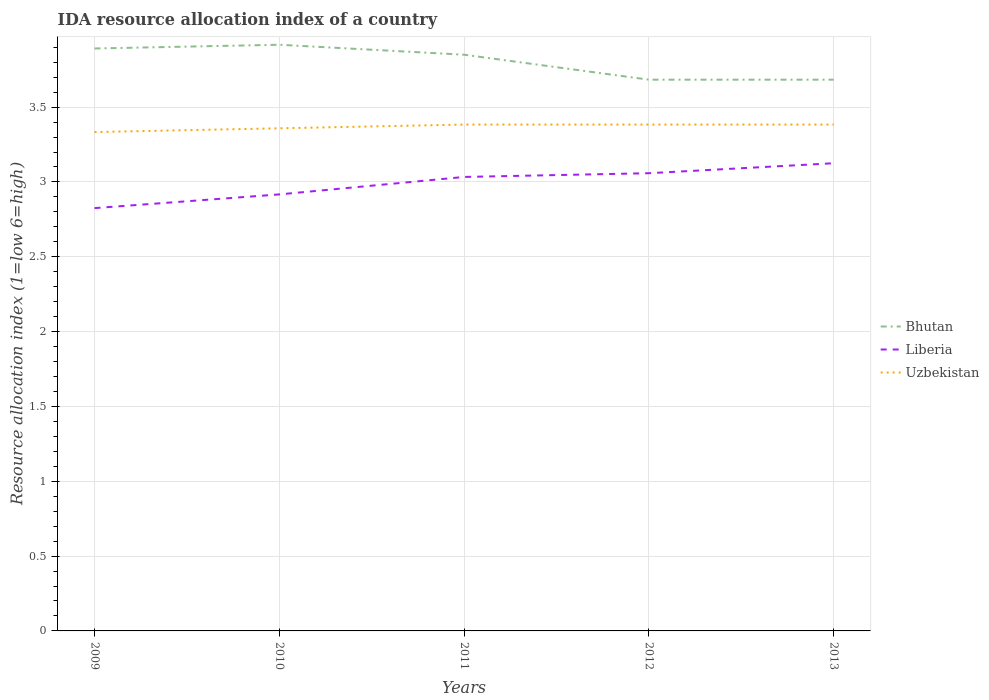How many different coloured lines are there?
Your answer should be compact. 3. Is the number of lines equal to the number of legend labels?
Provide a short and direct response. Yes. Across all years, what is the maximum IDA resource allocation index in Liberia?
Offer a terse response. 2.83. In which year was the IDA resource allocation index in Bhutan maximum?
Your answer should be compact. 2012. What is the total IDA resource allocation index in Uzbekistan in the graph?
Your response must be concise. -0.03. What is the difference between the highest and the second highest IDA resource allocation index in Uzbekistan?
Offer a terse response. 0.05. What is the difference between the highest and the lowest IDA resource allocation index in Uzbekistan?
Your answer should be very brief. 3. How many years are there in the graph?
Keep it short and to the point. 5. Are the values on the major ticks of Y-axis written in scientific E-notation?
Your answer should be very brief. No. Does the graph contain any zero values?
Your answer should be very brief. No. Where does the legend appear in the graph?
Ensure brevity in your answer.  Center right. How are the legend labels stacked?
Offer a terse response. Vertical. What is the title of the graph?
Your response must be concise. IDA resource allocation index of a country. What is the label or title of the X-axis?
Make the answer very short. Years. What is the label or title of the Y-axis?
Your answer should be compact. Resource allocation index (1=low 6=high). What is the Resource allocation index (1=low 6=high) in Bhutan in 2009?
Provide a short and direct response. 3.89. What is the Resource allocation index (1=low 6=high) of Liberia in 2009?
Keep it short and to the point. 2.83. What is the Resource allocation index (1=low 6=high) in Uzbekistan in 2009?
Keep it short and to the point. 3.33. What is the Resource allocation index (1=low 6=high) in Bhutan in 2010?
Your response must be concise. 3.92. What is the Resource allocation index (1=low 6=high) of Liberia in 2010?
Your response must be concise. 2.92. What is the Resource allocation index (1=low 6=high) in Uzbekistan in 2010?
Make the answer very short. 3.36. What is the Resource allocation index (1=low 6=high) in Bhutan in 2011?
Provide a succinct answer. 3.85. What is the Resource allocation index (1=low 6=high) in Liberia in 2011?
Keep it short and to the point. 3.03. What is the Resource allocation index (1=low 6=high) of Uzbekistan in 2011?
Keep it short and to the point. 3.38. What is the Resource allocation index (1=low 6=high) in Bhutan in 2012?
Make the answer very short. 3.68. What is the Resource allocation index (1=low 6=high) of Liberia in 2012?
Ensure brevity in your answer.  3.06. What is the Resource allocation index (1=low 6=high) of Uzbekistan in 2012?
Make the answer very short. 3.38. What is the Resource allocation index (1=low 6=high) of Bhutan in 2013?
Your answer should be compact. 3.68. What is the Resource allocation index (1=low 6=high) in Liberia in 2013?
Your answer should be compact. 3.12. What is the Resource allocation index (1=low 6=high) in Uzbekistan in 2013?
Offer a terse response. 3.38. Across all years, what is the maximum Resource allocation index (1=low 6=high) of Bhutan?
Ensure brevity in your answer.  3.92. Across all years, what is the maximum Resource allocation index (1=low 6=high) of Liberia?
Your answer should be compact. 3.12. Across all years, what is the maximum Resource allocation index (1=low 6=high) in Uzbekistan?
Offer a very short reply. 3.38. Across all years, what is the minimum Resource allocation index (1=low 6=high) in Bhutan?
Provide a short and direct response. 3.68. Across all years, what is the minimum Resource allocation index (1=low 6=high) of Liberia?
Give a very brief answer. 2.83. Across all years, what is the minimum Resource allocation index (1=low 6=high) in Uzbekistan?
Provide a succinct answer. 3.33. What is the total Resource allocation index (1=low 6=high) of Bhutan in the graph?
Make the answer very short. 19.02. What is the total Resource allocation index (1=low 6=high) of Liberia in the graph?
Your answer should be very brief. 14.96. What is the total Resource allocation index (1=low 6=high) of Uzbekistan in the graph?
Offer a very short reply. 16.84. What is the difference between the Resource allocation index (1=low 6=high) in Bhutan in 2009 and that in 2010?
Make the answer very short. -0.03. What is the difference between the Resource allocation index (1=low 6=high) of Liberia in 2009 and that in 2010?
Your answer should be very brief. -0.09. What is the difference between the Resource allocation index (1=low 6=high) in Uzbekistan in 2009 and that in 2010?
Keep it short and to the point. -0.03. What is the difference between the Resource allocation index (1=low 6=high) of Bhutan in 2009 and that in 2011?
Ensure brevity in your answer.  0.04. What is the difference between the Resource allocation index (1=low 6=high) of Liberia in 2009 and that in 2011?
Keep it short and to the point. -0.21. What is the difference between the Resource allocation index (1=low 6=high) of Bhutan in 2009 and that in 2012?
Offer a terse response. 0.21. What is the difference between the Resource allocation index (1=low 6=high) of Liberia in 2009 and that in 2012?
Ensure brevity in your answer.  -0.23. What is the difference between the Resource allocation index (1=low 6=high) of Bhutan in 2009 and that in 2013?
Make the answer very short. 0.21. What is the difference between the Resource allocation index (1=low 6=high) in Liberia in 2009 and that in 2013?
Ensure brevity in your answer.  -0.3. What is the difference between the Resource allocation index (1=low 6=high) in Uzbekistan in 2009 and that in 2013?
Ensure brevity in your answer.  -0.05. What is the difference between the Resource allocation index (1=low 6=high) of Bhutan in 2010 and that in 2011?
Offer a terse response. 0.07. What is the difference between the Resource allocation index (1=low 6=high) of Liberia in 2010 and that in 2011?
Make the answer very short. -0.12. What is the difference between the Resource allocation index (1=low 6=high) of Uzbekistan in 2010 and that in 2011?
Your answer should be very brief. -0.03. What is the difference between the Resource allocation index (1=low 6=high) in Bhutan in 2010 and that in 2012?
Offer a terse response. 0.23. What is the difference between the Resource allocation index (1=low 6=high) of Liberia in 2010 and that in 2012?
Offer a very short reply. -0.14. What is the difference between the Resource allocation index (1=low 6=high) in Uzbekistan in 2010 and that in 2012?
Give a very brief answer. -0.03. What is the difference between the Resource allocation index (1=low 6=high) in Bhutan in 2010 and that in 2013?
Offer a very short reply. 0.23. What is the difference between the Resource allocation index (1=low 6=high) in Liberia in 2010 and that in 2013?
Offer a very short reply. -0.21. What is the difference between the Resource allocation index (1=low 6=high) of Uzbekistan in 2010 and that in 2013?
Make the answer very short. -0.03. What is the difference between the Resource allocation index (1=low 6=high) of Liberia in 2011 and that in 2012?
Your answer should be compact. -0.03. What is the difference between the Resource allocation index (1=low 6=high) in Liberia in 2011 and that in 2013?
Provide a succinct answer. -0.09. What is the difference between the Resource allocation index (1=low 6=high) in Uzbekistan in 2011 and that in 2013?
Your response must be concise. 0. What is the difference between the Resource allocation index (1=low 6=high) of Liberia in 2012 and that in 2013?
Provide a short and direct response. -0.07. What is the difference between the Resource allocation index (1=low 6=high) in Bhutan in 2009 and the Resource allocation index (1=low 6=high) in Uzbekistan in 2010?
Give a very brief answer. 0.53. What is the difference between the Resource allocation index (1=low 6=high) of Liberia in 2009 and the Resource allocation index (1=low 6=high) of Uzbekistan in 2010?
Ensure brevity in your answer.  -0.53. What is the difference between the Resource allocation index (1=low 6=high) in Bhutan in 2009 and the Resource allocation index (1=low 6=high) in Liberia in 2011?
Give a very brief answer. 0.86. What is the difference between the Resource allocation index (1=low 6=high) of Bhutan in 2009 and the Resource allocation index (1=low 6=high) of Uzbekistan in 2011?
Your response must be concise. 0.51. What is the difference between the Resource allocation index (1=low 6=high) of Liberia in 2009 and the Resource allocation index (1=low 6=high) of Uzbekistan in 2011?
Make the answer very short. -0.56. What is the difference between the Resource allocation index (1=low 6=high) of Bhutan in 2009 and the Resource allocation index (1=low 6=high) of Uzbekistan in 2012?
Provide a short and direct response. 0.51. What is the difference between the Resource allocation index (1=low 6=high) of Liberia in 2009 and the Resource allocation index (1=low 6=high) of Uzbekistan in 2012?
Provide a succinct answer. -0.56. What is the difference between the Resource allocation index (1=low 6=high) in Bhutan in 2009 and the Resource allocation index (1=low 6=high) in Liberia in 2013?
Your answer should be compact. 0.77. What is the difference between the Resource allocation index (1=low 6=high) in Bhutan in 2009 and the Resource allocation index (1=low 6=high) in Uzbekistan in 2013?
Provide a short and direct response. 0.51. What is the difference between the Resource allocation index (1=low 6=high) of Liberia in 2009 and the Resource allocation index (1=low 6=high) of Uzbekistan in 2013?
Keep it short and to the point. -0.56. What is the difference between the Resource allocation index (1=low 6=high) in Bhutan in 2010 and the Resource allocation index (1=low 6=high) in Liberia in 2011?
Your response must be concise. 0.88. What is the difference between the Resource allocation index (1=low 6=high) of Bhutan in 2010 and the Resource allocation index (1=low 6=high) of Uzbekistan in 2011?
Give a very brief answer. 0.53. What is the difference between the Resource allocation index (1=low 6=high) of Liberia in 2010 and the Resource allocation index (1=low 6=high) of Uzbekistan in 2011?
Your response must be concise. -0.47. What is the difference between the Resource allocation index (1=low 6=high) of Bhutan in 2010 and the Resource allocation index (1=low 6=high) of Liberia in 2012?
Provide a short and direct response. 0.86. What is the difference between the Resource allocation index (1=low 6=high) of Bhutan in 2010 and the Resource allocation index (1=low 6=high) of Uzbekistan in 2012?
Offer a terse response. 0.53. What is the difference between the Resource allocation index (1=low 6=high) of Liberia in 2010 and the Resource allocation index (1=low 6=high) of Uzbekistan in 2012?
Provide a succinct answer. -0.47. What is the difference between the Resource allocation index (1=low 6=high) in Bhutan in 2010 and the Resource allocation index (1=low 6=high) in Liberia in 2013?
Your answer should be very brief. 0.79. What is the difference between the Resource allocation index (1=low 6=high) of Bhutan in 2010 and the Resource allocation index (1=low 6=high) of Uzbekistan in 2013?
Offer a terse response. 0.53. What is the difference between the Resource allocation index (1=low 6=high) of Liberia in 2010 and the Resource allocation index (1=low 6=high) of Uzbekistan in 2013?
Give a very brief answer. -0.47. What is the difference between the Resource allocation index (1=low 6=high) of Bhutan in 2011 and the Resource allocation index (1=low 6=high) of Liberia in 2012?
Your answer should be compact. 0.79. What is the difference between the Resource allocation index (1=low 6=high) in Bhutan in 2011 and the Resource allocation index (1=low 6=high) in Uzbekistan in 2012?
Your answer should be very brief. 0.47. What is the difference between the Resource allocation index (1=low 6=high) of Liberia in 2011 and the Resource allocation index (1=low 6=high) of Uzbekistan in 2012?
Ensure brevity in your answer.  -0.35. What is the difference between the Resource allocation index (1=low 6=high) in Bhutan in 2011 and the Resource allocation index (1=low 6=high) in Liberia in 2013?
Your answer should be very brief. 0.72. What is the difference between the Resource allocation index (1=low 6=high) in Bhutan in 2011 and the Resource allocation index (1=low 6=high) in Uzbekistan in 2013?
Your answer should be compact. 0.47. What is the difference between the Resource allocation index (1=low 6=high) in Liberia in 2011 and the Resource allocation index (1=low 6=high) in Uzbekistan in 2013?
Provide a short and direct response. -0.35. What is the difference between the Resource allocation index (1=low 6=high) in Bhutan in 2012 and the Resource allocation index (1=low 6=high) in Liberia in 2013?
Ensure brevity in your answer.  0.56. What is the difference between the Resource allocation index (1=low 6=high) of Bhutan in 2012 and the Resource allocation index (1=low 6=high) of Uzbekistan in 2013?
Offer a very short reply. 0.3. What is the difference between the Resource allocation index (1=low 6=high) in Liberia in 2012 and the Resource allocation index (1=low 6=high) in Uzbekistan in 2013?
Give a very brief answer. -0.33. What is the average Resource allocation index (1=low 6=high) in Bhutan per year?
Offer a very short reply. 3.81. What is the average Resource allocation index (1=low 6=high) in Liberia per year?
Provide a short and direct response. 2.99. What is the average Resource allocation index (1=low 6=high) of Uzbekistan per year?
Your answer should be compact. 3.37. In the year 2009, what is the difference between the Resource allocation index (1=low 6=high) in Bhutan and Resource allocation index (1=low 6=high) in Liberia?
Offer a very short reply. 1.07. In the year 2009, what is the difference between the Resource allocation index (1=low 6=high) of Bhutan and Resource allocation index (1=low 6=high) of Uzbekistan?
Provide a short and direct response. 0.56. In the year 2009, what is the difference between the Resource allocation index (1=low 6=high) of Liberia and Resource allocation index (1=low 6=high) of Uzbekistan?
Your answer should be compact. -0.51. In the year 2010, what is the difference between the Resource allocation index (1=low 6=high) of Bhutan and Resource allocation index (1=low 6=high) of Uzbekistan?
Your answer should be compact. 0.56. In the year 2010, what is the difference between the Resource allocation index (1=low 6=high) of Liberia and Resource allocation index (1=low 6=high) of Uzbekistan?
Provide a short and direct response. -0.44. In the year 2011, what is the difference between the Resource allocation index (1=low 6=high) in Bhutan and Resource allocation index (1=low 6=high) in Liberia?
Your response must be concise. 0.82. In the year 2011, what is the difference between the Resource allocation index (1=low 6=high) in Bhutan and Resource allocation index (1=low 6=high) in Uzbekistan?
Make the answer very short. 0.47. In the year 2011, what is the difference between the Resource allocation index (1=low 6=high) of Liberia and Resource allocation index (1=low 6=high) of Uzbekistan?
Offer a terse response. -0.35. In the year 2012, what is the difference between the Resource allocation index (1=low 6=high) of Bhutan and Resource allocation index (1=low 6=high) of Liberia?
Keep it short and to the point. 0.62. In the year 2012, what is the difference between the Resource allocation index (1=low 6=high) of Bhutan and Resource allocation index (1=low 6=high) of Uzbekistan?
Give a very brief answer. 0.3. In the year 2012, what is the difference between the Resource allocation index (1=low 6=high) in Liberia and Resource allocation index (1=low 6=high) in Uzbekistan?
Give a very brief answer. -0.33. In the year 2013, what is the difference between the Resource allocation index (1=low 6=high) in Bhutan and Resource allocation index (1=low 6=high) in Liberia?
Your response must be concise. 0.56. In the year 2013, what is the difference between the Resource allocation index (1=low 6=high) of Bhutan and Resource allocation index (1=low 6=high) of Uzbekistan?
Ensure brevity in your answer.  0.3. In the year 2013, what is the difference between the Resource allocation index (1=low 6=high) in Liberia and Resource allocation index (1=low 6=high) in Uzbekistan?
Give a very brief answer. -0.26. What is the ratio of the Resource allocation index (1=low 6=high) of Bhutan in 2009 to that in 2010?
Give a very brief answer. 0.99. What is the ratio of the Resource allocation index (1=low 6=high) in Liberia in 2009 to that in 2010?
Offer a terse response. 0.97. What is the ratio of the Resource allocation index (1=low 6=high) in Bhutan in 2009 to that in 2011?
Make the answer very short. 1.01. What is the ratio of the Resource allocation index (1=low 6=high) in Liberia in 2009 to that in 2011?
Ensure brevity in your answer.  0.93. What is the ratio of the Resource allocation index (1=low 6=high) in Uzbekistan in 2009 to that in 2011?
Your response must be concise. 0.99. What is the ratio of the Resource allocation index (1=low 6=high) of Bhutan in 2009 to that in 2012?
Provide a short and direct response. 1.06. What is the ratio of the Resource allocation index (1=low 6=high) of Liberia in 2009 to that in 2012?
Ensure brevity in your answer.  0.92. What is the ratio of the Resource allocation index (1=low 6=high) in Uzbekistan in 2009 to that in 2012?
Your response must be concise. 0.99. What is the ratio of the Resource allocation index (1=low 6=high) of Bhutan in 2009 to that in 2013?
Provide a succinct answer. 1.06. What is the ratio of the Resource allocation index (1=low 6=high) of Liberia in 2009 to that in 2013?
Give a very brief answer. 0.9. What is the ratio of the Resource allocation index (1=low 6=high) of Uzbekistan in 2009 to that in 2013?
Your response must be concise. 0.99. What is the ratio of the Resource allocation index (1=low 6=high) in Bhutan in 2010 to that in 2011?
Offer a terse response. 1.02. What is the ratio of the Resource allocation index (1=low 6=high) of Liberia in 2010 to that in 2011?
Offer a terse response. 0.96. What is the ratio of the Resource allocation index (1=low 6=high) in Bhutan in 2010 to that in 2012?
Provide a succinct answer. 1.06. What is the ratio of the Resource allocation index (1=low 6=high) of Liberia in 2010 to that in 2012?
Ensure brevity in your answer.  0.95. What is the ratio of the Resource allocation index (1=low 6=high) in Uzbekistan in 2010 to that in 2012?
Your response must be concise. 0.99. What is the ratio of the Resource allocation index (1=low 6=high) in Bhutan in 2010 to that in 2013?
Give a very brief answer. 1.06. What is the ratio of the Resource allocation index (1=low 6=high) in Bhutan in 2011 to that in 2012?
Keep it short and to the point. 1.05. What is the ratio of the Resource allocation index (1=low 6=high) in Liberia in 2011 to that in 2012?
Keep it short and to the point. 0.99. What is the ratio of the Resource allocation index (1=low 6=high) in Uzbekistan in 2011 to that in 2012?
Keep it short and to the point. 1. What is the ratio of the Resource allocation index (1=low 6=high) in Bhutan in 2011 to that in 2013?
Provide a short and direct response. 1.05. What is the ratio of the Resource allocation index (1=low 6=high) of Liberia in 2011 to that in 2013?
Offer a very short reply. 0.97. What is the ratio of the Resource allocation index (1=low 6=high) of Bhutan in 2012 to that in 2013?
Offer a very short reply. 1. What is the ratio of the Resource allocation index (1=low 6=high) in Liberia in 2012 to that in 2013?
Ensure brevity in your answer.  0.98. What is the ratio of the Resource allocation index (1=low 6=high) of Uzbekistan in 2012 to that in 2013?
Offer a very short reply. 1. What is the difference between the highest and the second highest Resource allocation index (1=low 6=high) in Bhutan?
Give a very brief answer. 0.03. What is the difference between the highest and the second highest Resource allocation index (1=low 6=high) in Liberia?
Offer a very short reply. 0.07. What is the difference between the highest and the lowest Resource allocation index (1=low 6=high) of Bhutan?
Provide a short and direct response. 0.23. What is the difference between the highest and the lowest Resource allocation index (1=low 6=high) in Liberia?
Provide a succinct answer. 0.3. 